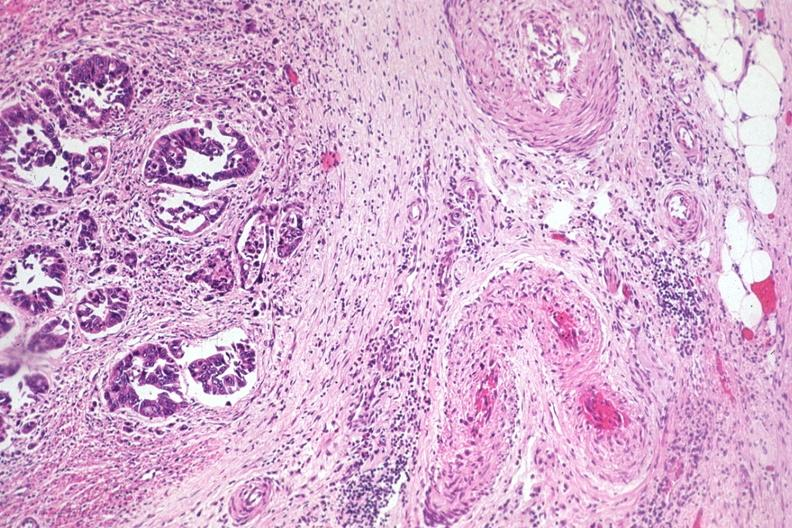s colon present?
Answer the question using a single word or phrase. Yes 